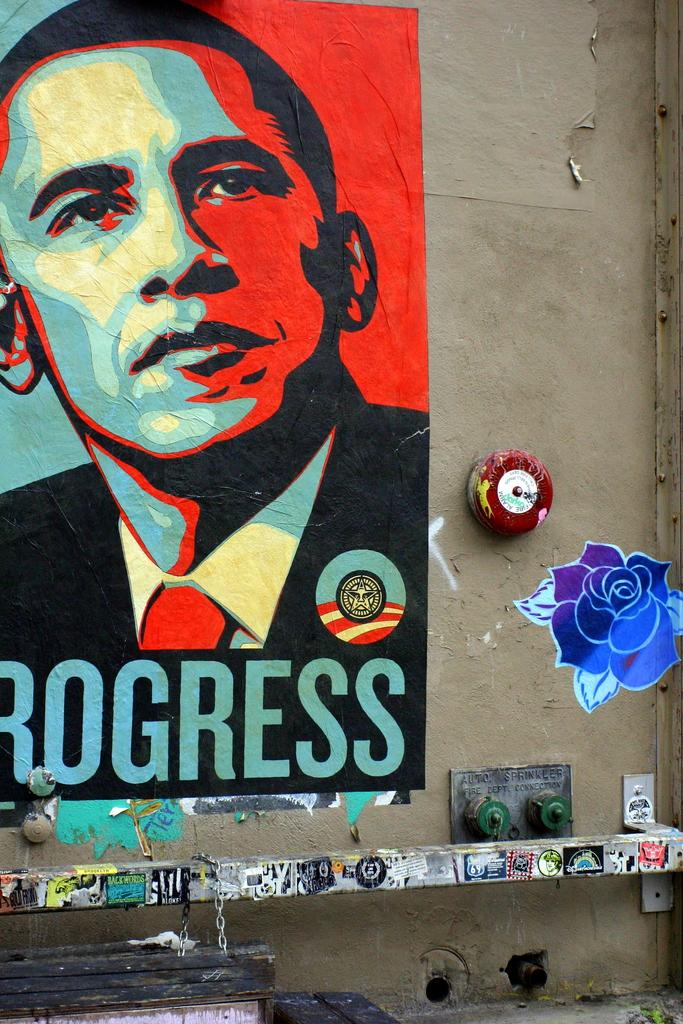What is depicted in the image? There is a picture of a person and a rose in the image. Where are the picture of a person and the rose located? The picture of a person and the rose are painted on a wall. What else is present in the image along with the picture and the rose? There is text associated with the picture and the rose. What type of silver object is being used to express a feeling in the image? There is no silver object or expression of feeling present in the image; it features a picture of a person and a rose painted on a wall with associated text. 